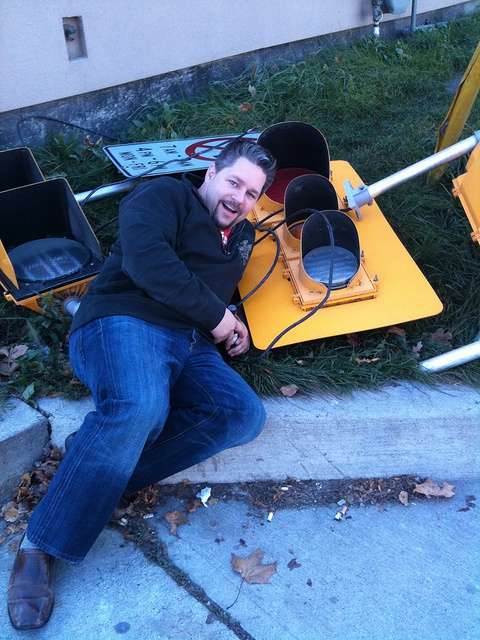Describe the objects in this image and their specific colors. I can see people in lightblue, navy, black, blue, and darkblue tones, traffic light in lightblue, gold, black, orange, and khaki tones, and traffic light in lightblue, black, navy, darkblue, and blue tones in this image. 